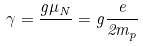Convert formula to latex. <formula><loc_0><loc_0><loc_500><loc_500>\gamma = { \frac { g \mu _ { N } } { } } = g { \frac { e } { 2 m _ { p } } }</formula> 